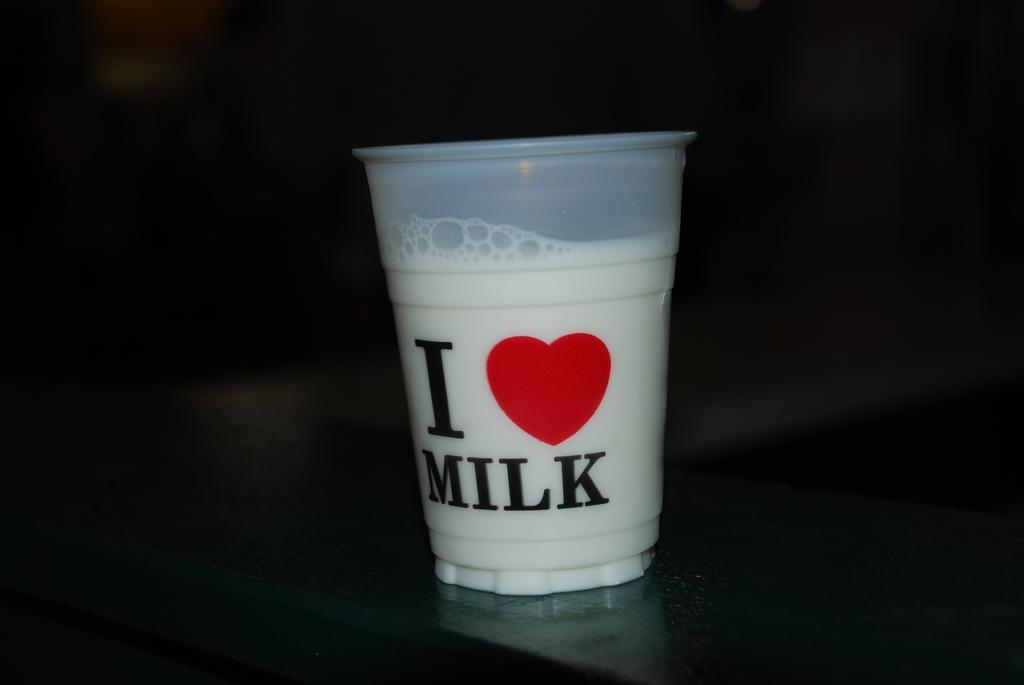<image>
Render a clear and concise summary of the photo. the word milk is on the cup with bubbles on it 